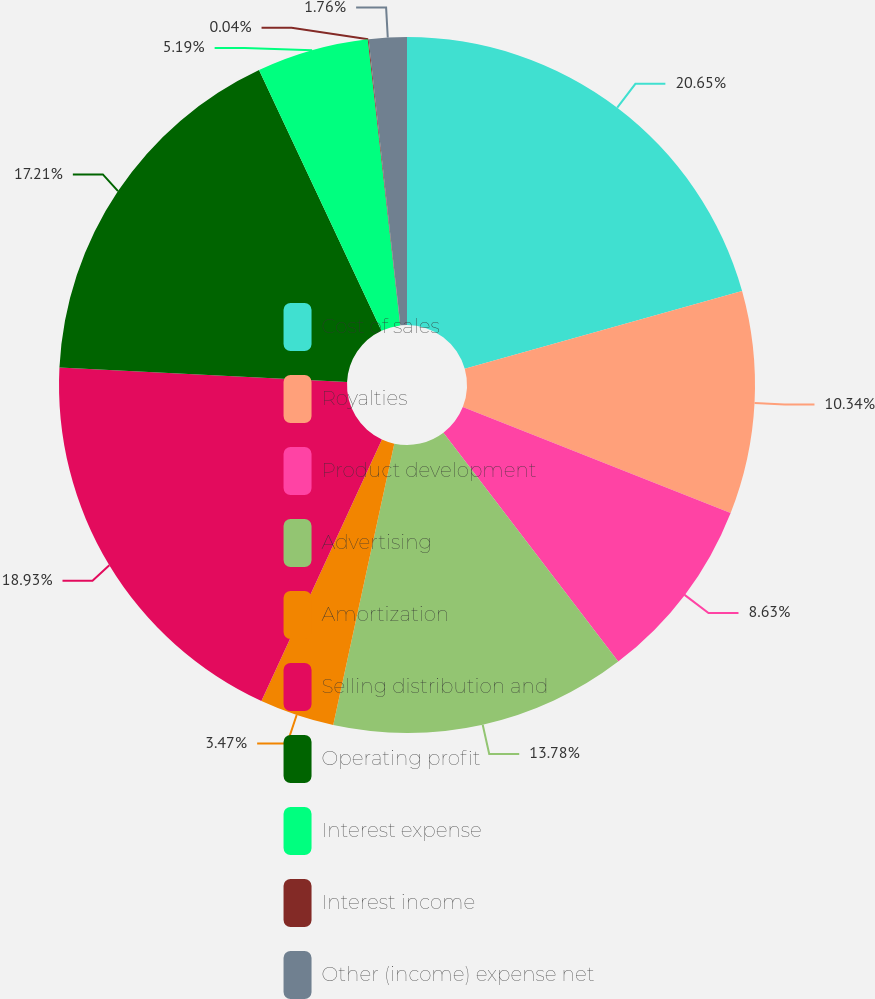Convert chart to OTSL. <chart><loc_0><loc_0><loc_500><loc_500><pie_chart><fcel>Cost of sales<fcel>Royalties<fcel>Product development<fcel>Advertising<fcel>Amortization<fcel>Selling distribution and<fcel>Operating profit<fcel>Interest expense<fcel>Interest income<fcel>Other (income) expense net<nl><fcel>20.65%<fcel>10.34%<fcel>8.63%<fcel>13.78%<fcel>3.47%<fcel>18.93%<fcel>17.21%<fcel>5.19%<fcel>0.04%<fcel>1.76%<nl></chart> 